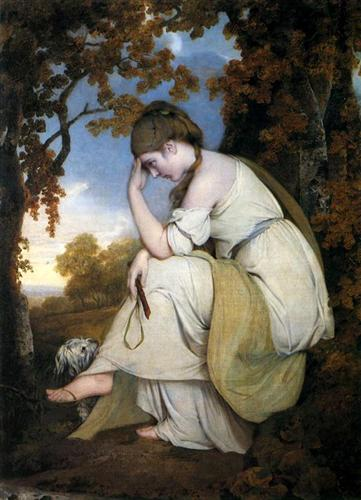What can you infer about the relationship between the woman and the dog in the painting? The presence of the dog near the woman implies a sense of companionship and loyalty. The dog appears at ease and attentive, suggesting a close bond with the woman. This companionship often symbolizes fidelity and the comfort of a loyal friend, which complements the woman's contemplative pose, adding a layer of emotional depth and intimacy to the scene. 